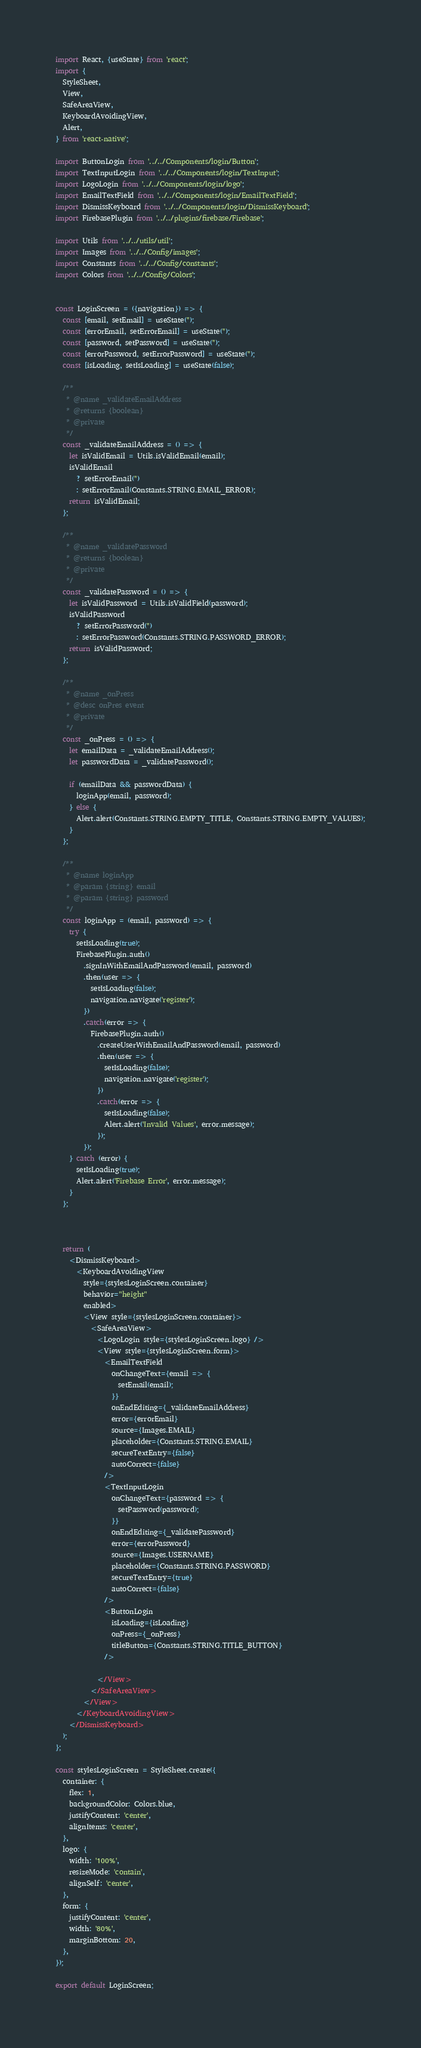Convert code to text. <code><loc_0><loc_0><loc_500><loc_500><_JavaScript_>import React, {useState} from 'react';
import {
  StyleSheet,
  View,
  SafeAreaView,
  KeyboardAvoidingView,
  Alert,
} from 'react-native';

import ButtonLogin from '../../Components/login/Button';
import TextInputLogin from '../../Components/login/TextInput';
import LogoLogin from '../../Components/login/logo';
import EmailTextField from '../../Components/login/EmailTextField';
import DismissKeyboard from '../../Components/login/DismissKeyboard';
import FirebasePlugin from '../../plugins/firebase/Firebase';

import Utils from '../../utils/util';
import Images from '../../Config/images';
import Constants from '../../Config/constants';
import Colors from '../../Config/Colors';


const LoginScreen = ({navigation}) => {
  const [email, setEmail] = useState('');
  const [errorEmail, setErrorEmail] = useState('');
  const [password, setPassword] = useState('');
  const [errorPassword, setErrorPassword] = useState('');
  const [isLoading, setIsLoading] = useState(false);

  /**
   * @name _validateEmailAddress
   * @returns {boolean}
   * @private
   */
  const _validateEmailAddress = () => {
    let isValidEmail = Utils.isValidEmail(email);
    isValidEmail
      ? setErrorEmail('')
      : setErrorEmail(Constants.STRING.EMAIL_ERROR);
    return isValidEmail;
  };

  /**
   * @name _validatePassword
   * @returns {boolean}
   * @private
   */
  const _validatePassword = () => {
    let isValidPassword = Utils.isValidField(password);
    isValidPassword
      ? setErrorPassword('')
      : setErrorPassword(Constants.STRING.PASSWORD_ERROR);
    return isValidPassword;
  };

  /**
   * @name _onPress
   * @desc onPres event
   * @private
   */
  const _onPress = () => {
    let emailData = _validateEmailAddress();
    let passwordData = _validatePassword();

    if (emailData && passwordData) {
      loginApp(email, password);
    } else {
      Alert.alert(Constants.STRING.EMPTY_TITLE, Constants.STRING.EMPTY_VALUES);
    }
  };

  /**
   * @name loginApp
   * @param {string} email
   * @param {string} password
   */
  const loginApp = (email, password) => {
    try {
      setIsLoading(true);
      FirebasePlugin.auth()
        .signInWithEmailAndPassword(email, password)
        .then(user => {
          setIsLoading(false);
          navigation.navigate('register');
        })
        .catch(error => {
          FirebasePlugin.auth()
            .createUserWithEmailAndPassword(email, password)
            .then(user => {
              setIsLoading(false);
              navigation.navigate('register');
            })
            .catch(error => {
              setIsLoading(false);
              Alert.alert('Invalid Values', error.message);
            });
        });
    } catch (error) {
      setIsLoading(true);
      Alert.alert('Firebase Error', error.message);
    }
  };
  
  

  return (
    <DismissKeyboard>
      <KeyboardAvoidingView
        style={stylesLoginScreen.container}
        behavior="height"
        enabled>
        <View style={stylesLoginScreen.container}>
          <SafeAreaView>
            <LogoLogin style={stylesLoginScreen.logo} />
            <View style={stylesLoginScreen.form}>
              <EmailTextField
                onChangeText={email => {
                  setEmail(email);
                }}
                onEndEditing={_validateEmailAddress}
                error={errorEmail}
                source={Images.EMAIL}
                placeholder={Constants.STRING.EMAIL}
                secureTextEntry={false}
                autoCorrect={false}
              />
              <TextInputLogin
                onChangeText={password => {
                  setPassword(password);
                }}
                onEndEditing={_validatePassword}
                error={errorPassword}
                source={Images.USERNAME}
                placeholder={Constants.STRING.PASSWORD}
                secureTextEntry={true}
                autoCorrect={false}
              />
              <ButtonLogin
                isLoading={isLoading}
                onPress={_onPress}
                titleButton={Constants.STRING.TITLE_BUTTON}
              />
              
            </View>
          </SafeAreaView>
        </View>
      </KeyboardAvoidingView>
    </DismissKeyboard>
  );
};

const stylesLoginScreen = StyleSheet.create({
  container: {
    flex: 1,
    backgroundColor: Colors.blue,
    justifyContent: 'center',
    alignItems: 'center',
  },
  logo: {
    width: '100%',
    resizeMode: 'contain',
    alignSelf: 'center',
  },
  form: {
    justifyContent: 'center',
    width: '80%',
    marginBottom: 20,
  },
});

export default LoginScreen;</code> 